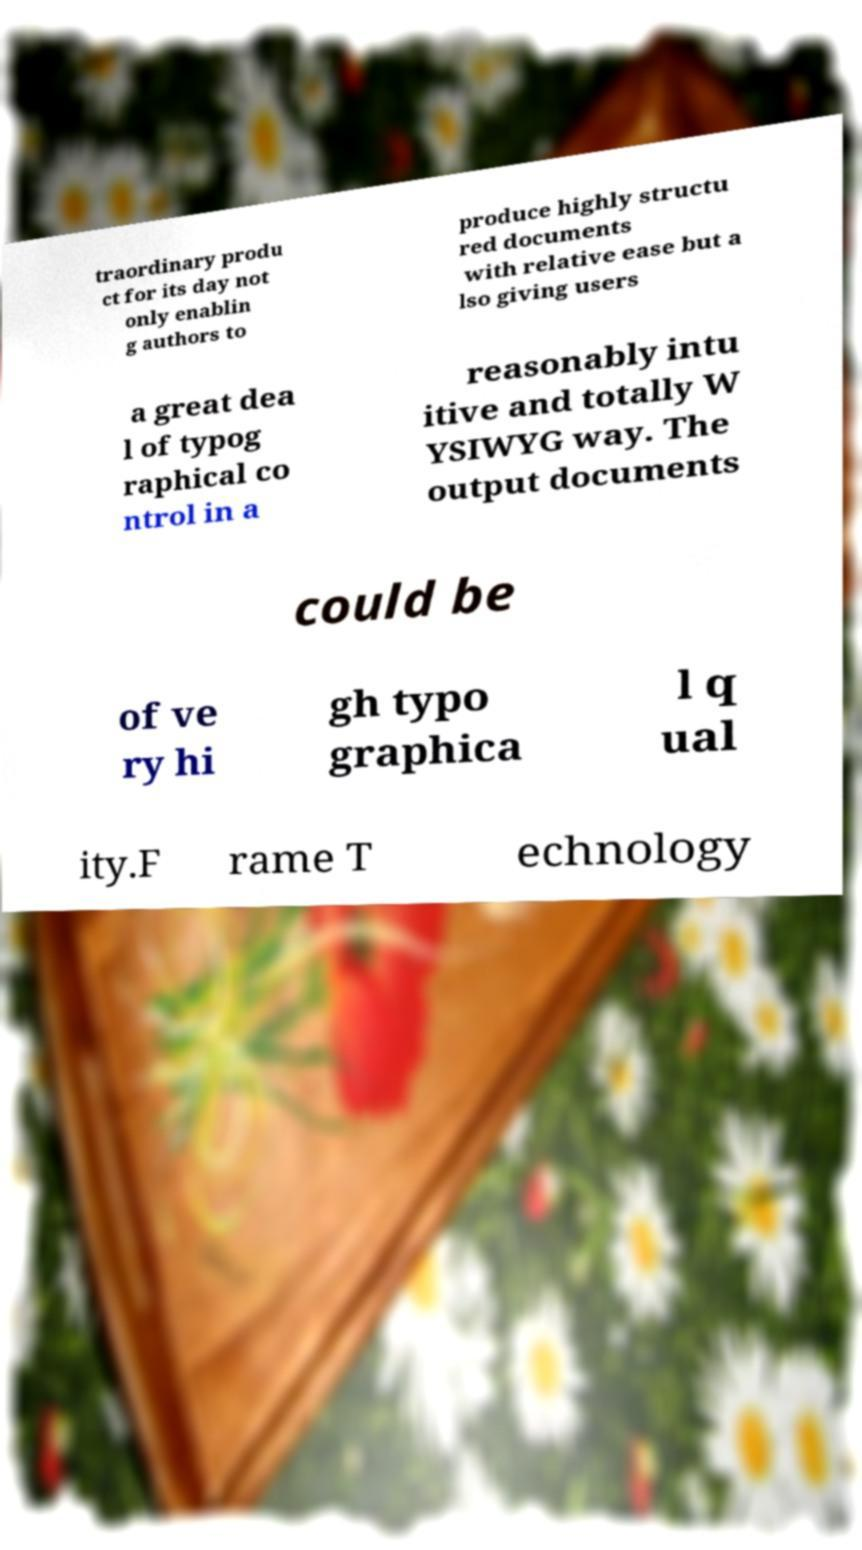Please identify and transcribe the text found in this image. traordinary produ ct for its day not only enablin g authors to produce highly structu red documents with relative ease but a lso giving users a great dea l of typog raphical co ntrol in a reasonably intu itive and totally W YSIWYG way. The output documents could be of ve ry hi gh typo graphica l q ual ity.F rame T echnology 